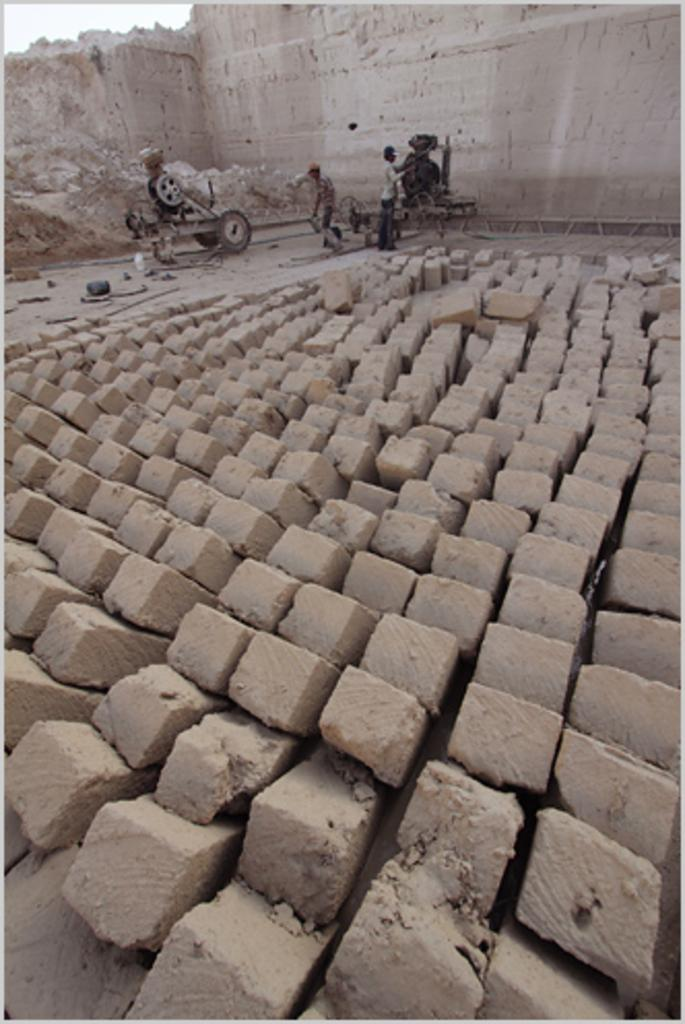What type of material is present in the image? There are bricks in the image. What is the surface on which the bricks are placed? There is ground visible in the image. What is placed on the ground? There are objects on the ground. What type of equipment can be seen in the image? There are machines in the image. Are there any people present in the image? Yes, there are people in the image. What structure is visible in the image? There is a wall in the image. What part of the natural environment is visible in the image? The sky is visible in the image. What type of property does the porter own in the image? There is no porter or property mentioned in the image. How many brothers are present in the image? There is no mention of any brothers in the image. 